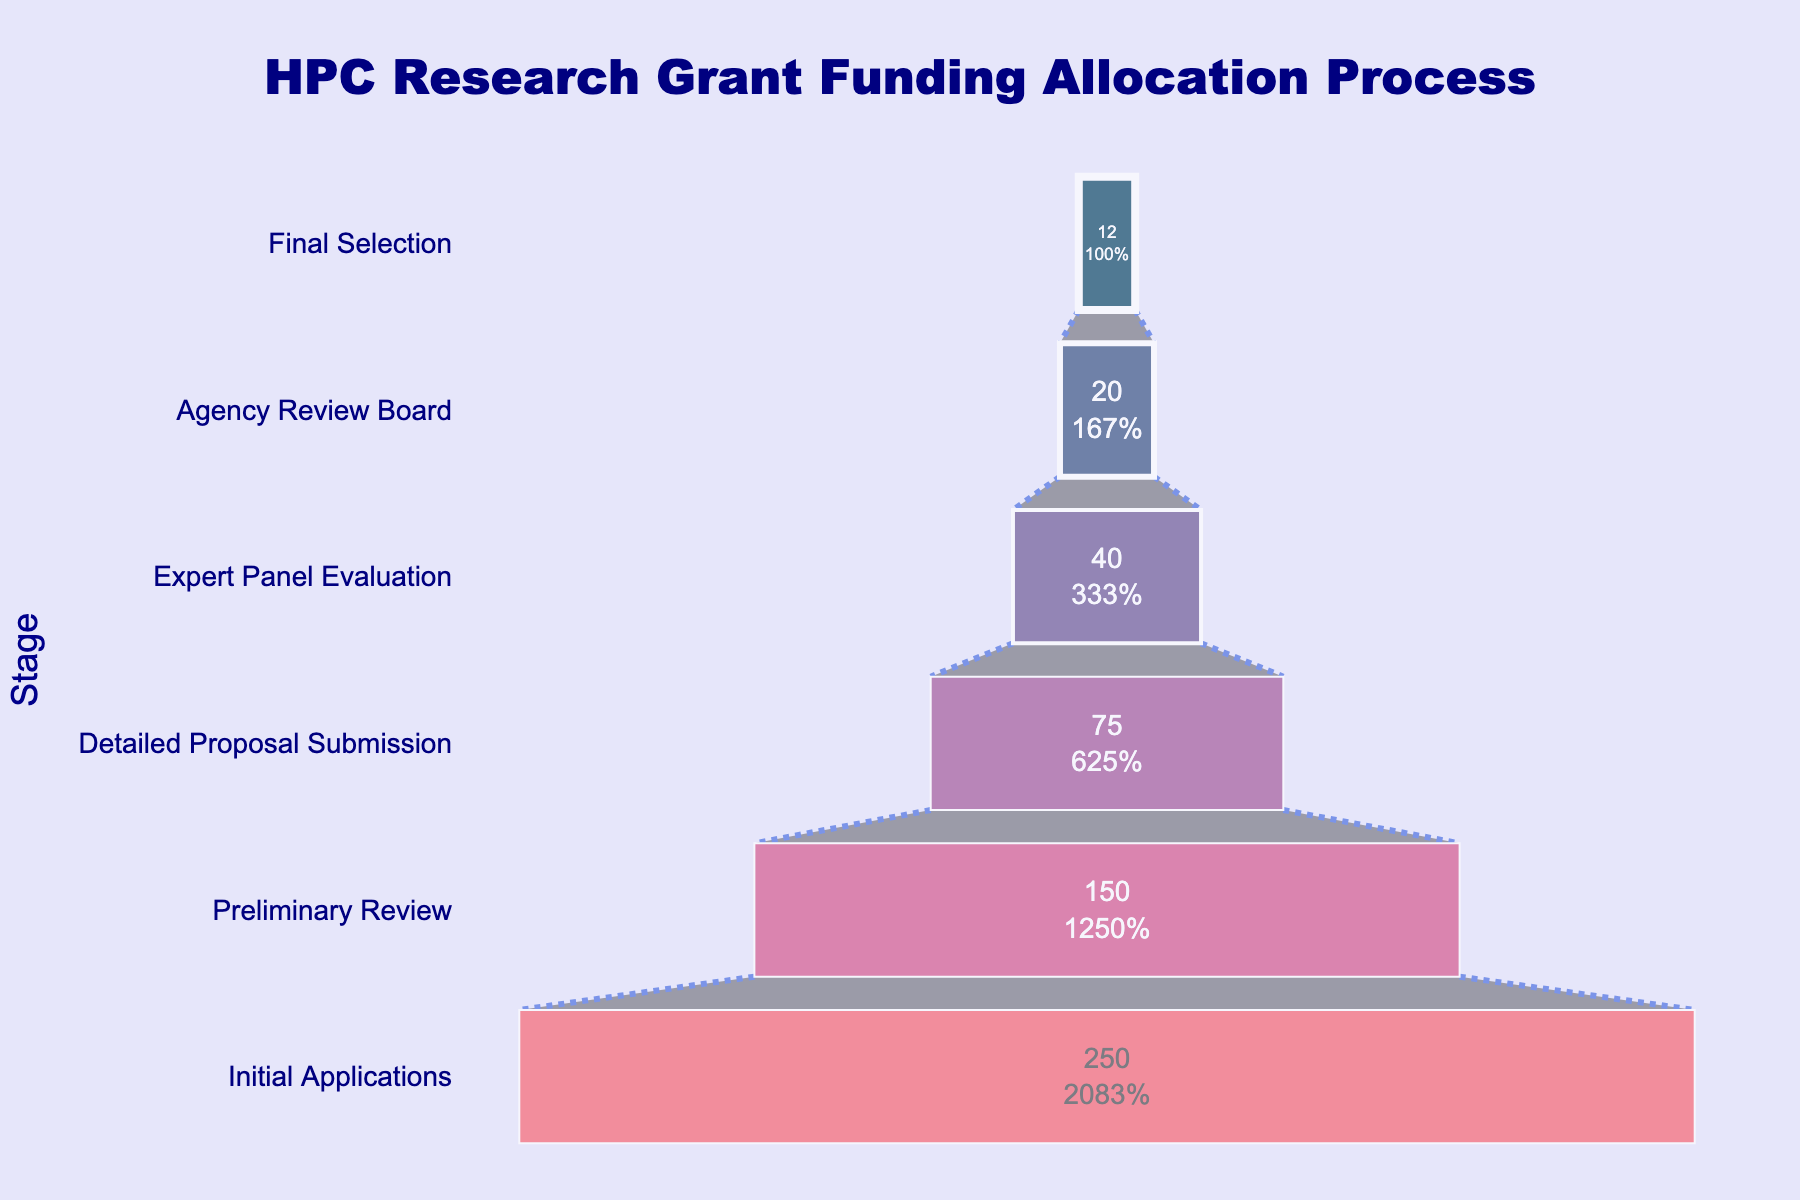What is the title of the chart? The title is located at the top center of the chart. It reads "HPC Research Grant Funding Allocation Process".
Answer: HPC Research Grant Funding Allocation Process How many applicants are there at the Initial Applications stage? The chart shows the number of applicants inside the bar of each stage. For the Initial Applications stage, it shows 250 applicants.
Answer: 250 At which stage does the number of applicants drop below 50 for the first time? By following the stages sequentially from top to bottom, the number of applicants first drops below 50 at the Expert Panel Evaluation stage with 40 applicants.
Answer: Expert Panel Evaluation What is the percentage of applicants proceeding from the Preliminary Review to the Detailed Proposal Submission stage? The Preliminary Review stage has 150 applicants, and the Detailed Proposal Submission stage has 75. The percentage is calculated as (75/150) * 100%.
Answer: 50% Which stage has the highest rate of drop-off in terms of the number of applicants? To find which stage has the highest drop-off rate, we compare the absolute differences in the number of applicants between consecutive stages. The largest drop-off is from Initial Applications (250) to Preliminary Review (150), a loss of 100 applicants.
Answer: From Initial Applications to Preliminary Review How many stages are there in total? The y-axis lists all the stages. By counting them, we find there are six stages in total.
Answer: 6 What is the difference in the number of applicants between the Agency Review Board and the Final Selection stage? The number of applicants at the Agency Review Board stage is 20, and at the Final Selection stage is 12. The difference is 20 - 12.
Answer: 8 What is the cumulative percentage of applicants that make it to the Final Selection stage from the Initial Applications stage? Starting with 250 applicants and narrowing to 12 at the Final Selection stage, the cumulative percentage is calculated as (12/250) * 100%.
Answer: 4.8% Which stage has the narrowest funnel segment in terms of visual width? Visually, the Final Selection stage appears to be the narrowest part of the funnel as it represents the fewest number of applicants (12).
Answer: Final Selection 